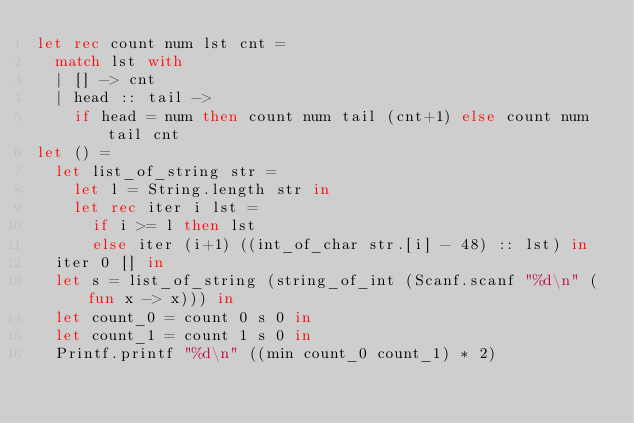<code> <loc_0><loc_0><loc_500><loc_500><_OCaml_>let rec count num lst cnt =
  match lst with
  | [] -> cnt
  | head :: tail ->
    if head = num then count num tail (cnt+1) else count num tail cnt
let () =
  let list_of_string str =
    let l = String.length str in
    let rec iter i lst =
      if i >= l then lst
      else iter (i+1) ((int_of_char str.[i] - 48) :: lst) in
  iter 0 [] in
  let s = list_of_string (string_of_int (Scanf.scanf "%d\n" (fun x -> x))) in
  let count_0 = count 0 s 0 in
  let count_1 = count 1 s 0 in
  Printf.printf "%d\n" ((min count_0 count_1) * 2)</code> 